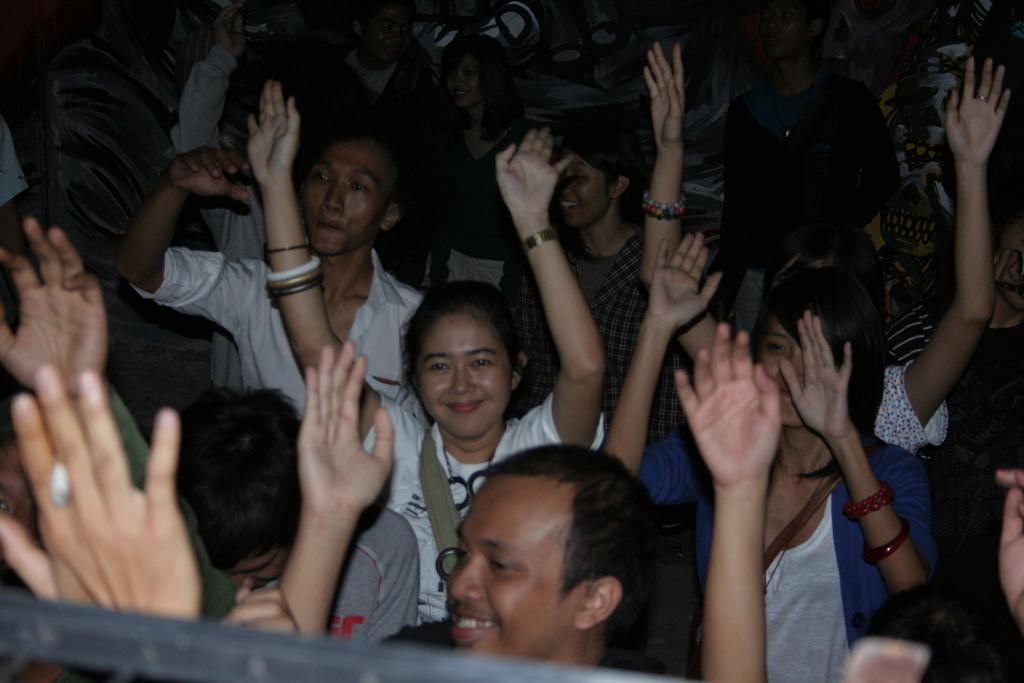How many people are present in the image? There are many people in the image. Can you describe any specific detail about one of the people? Yes, a girl is wearing bangles. What is the color of the background in the image? The background of the image is dark. What type of hen can be seen in the image? There is no hen present in the image. What role does the government play in the image? The image does not depict any government involvement or activity. 